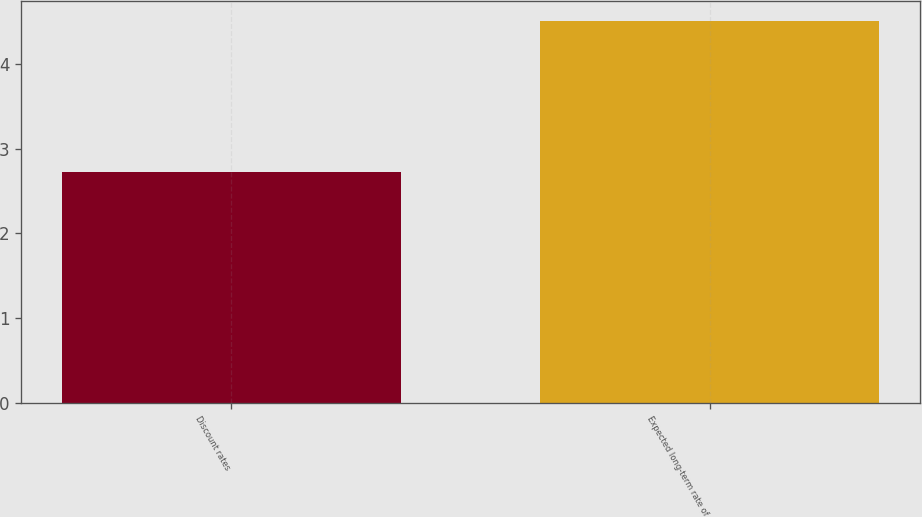<chart> <loc_0><loc_0><loc_500><loc_500><bar_chart><fcel>Discount rates<fcel>Expected long-term rate of<nl><fcel>2.72<fcel>4.51<nl></chart> 